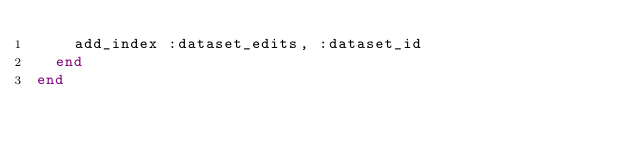<code> <loc_0><loc_0><loc_500><loc_500><_Ruby_>    add_index :dataset_edits, :dataset_id
  end
end
</code> 